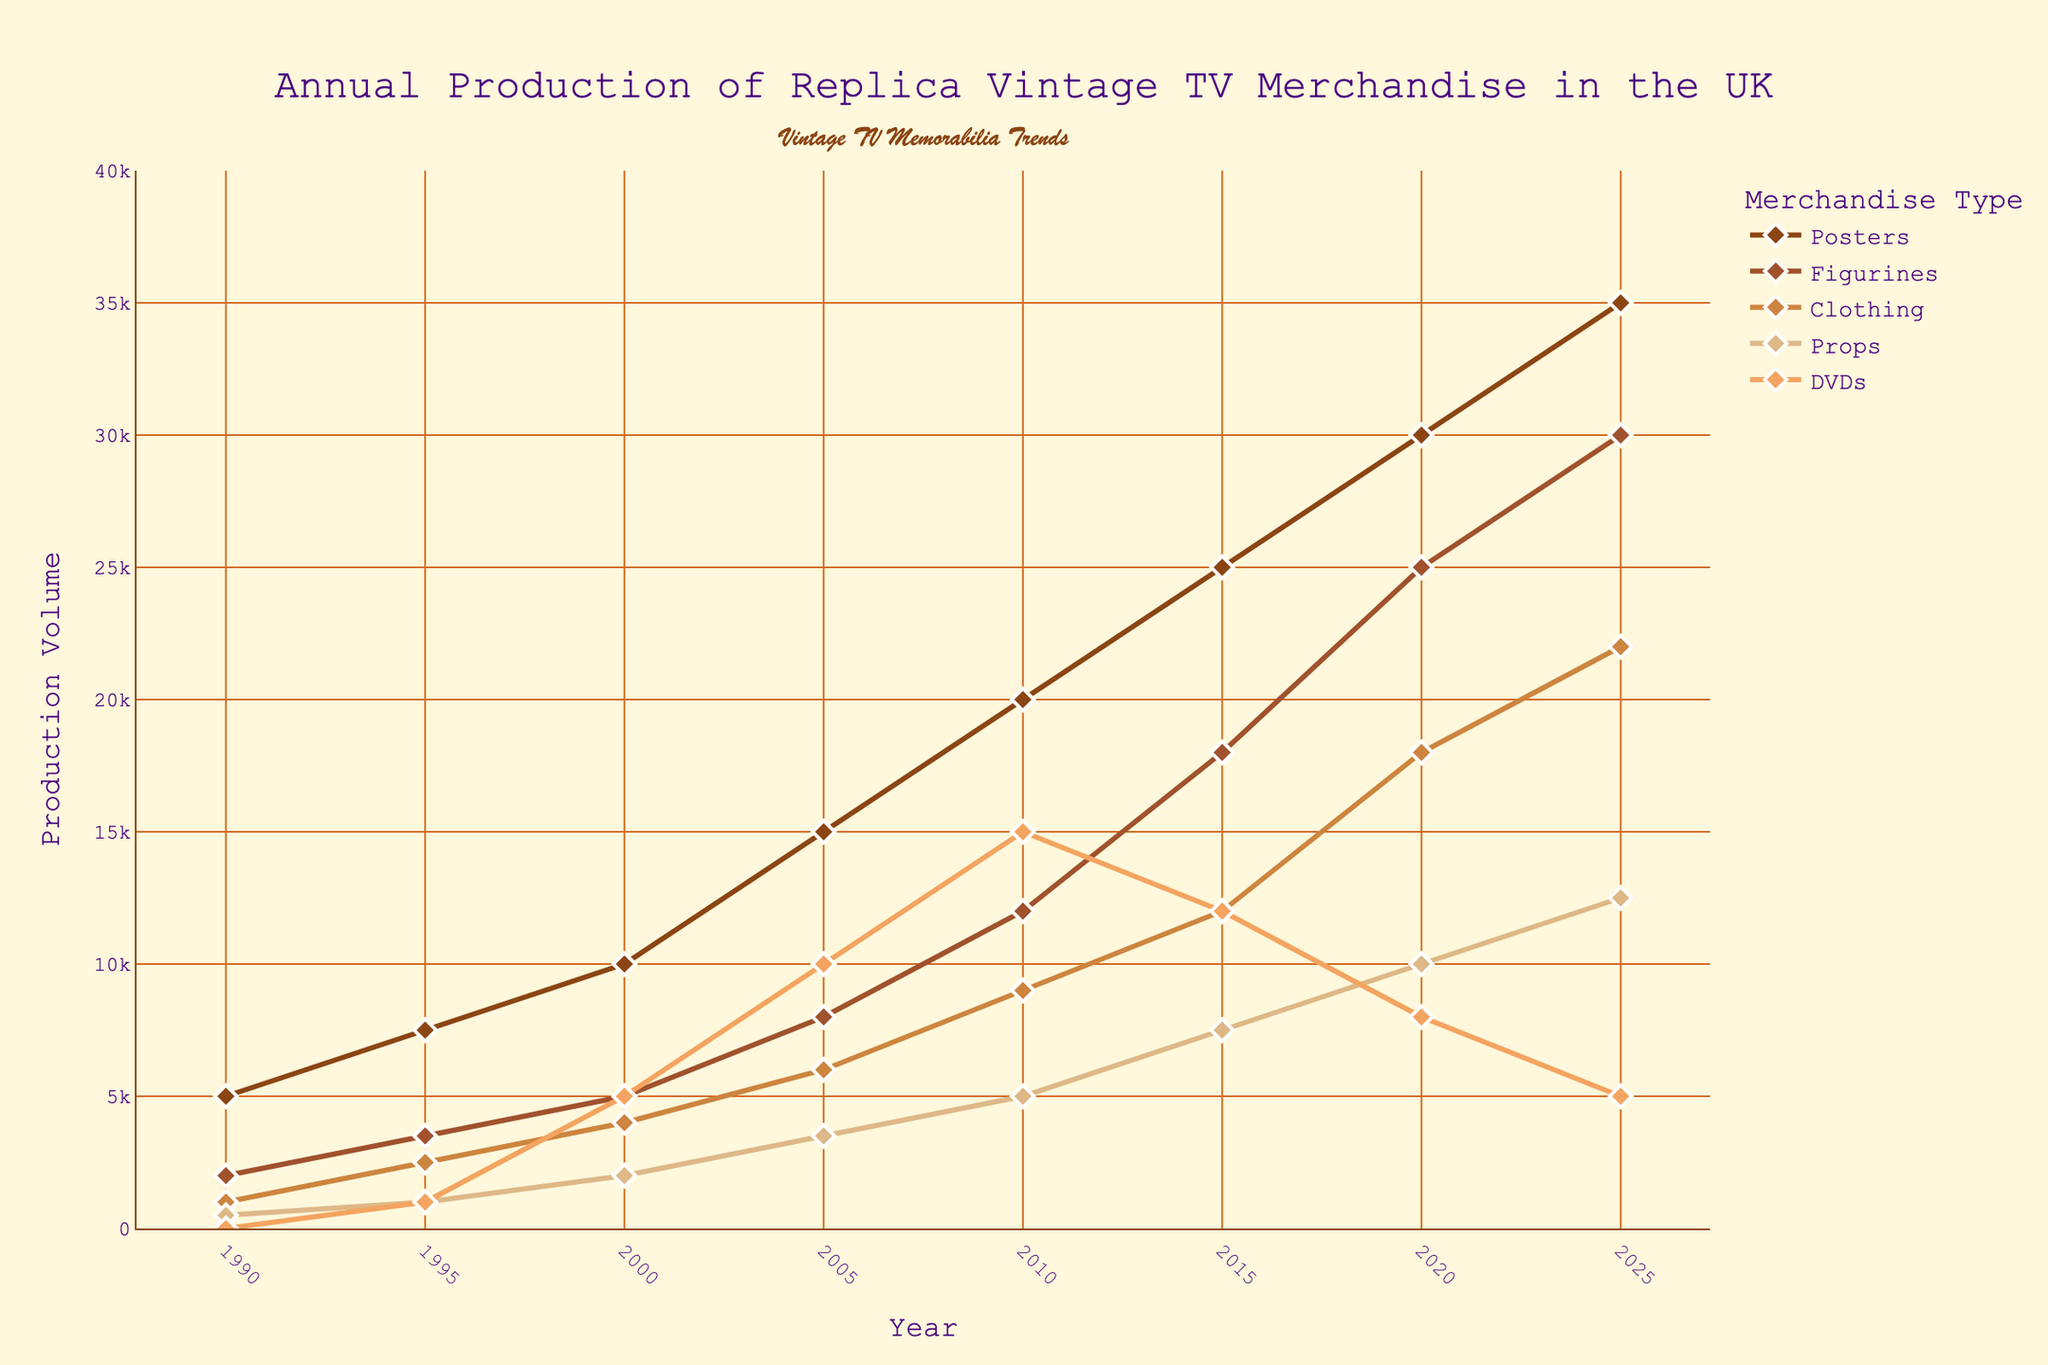What is the difference in the production volume of Posters between the years 1990 and 2025? To find the difference, locate the production volume of Posters for the years 1990 and 2025 on the y-axis. In 1990, Posters' production volume is 5000 units, and in 2025, it is 35000 units. Subtract the 1990 value from the 2025 value: 35000 - 5000 = 30000.
Answer: 30000 Which merchandise type had the highest production volume in 2010? Observe the distribution of data markers for the year 2010 across all merchandise types. The highest y-axis value is for DVDs, which stands at 15000 units.
Answer: DVDs In which year did Clothing production reach 12000 units? Trace the line corresponding to Clothing across the x-axis until the marker reaches the 12000 unit level on the y-axis. The year where this occurs is 2015.
Answer: 2015 How does the production volume of DVDs in 2005 compare to 2025? Identify the data points for DVDs in the years 2005 and 2025. In 2005, the volume is 10000 units, while in 2025 it reduces to 5000 units. Comparing these values, the production volume of DVDs in 2025 is half of what it was in 2005.
Answer: Decreased by half What is the average production volume of Props over the period from 1990 to 2025? Sum the production volumes of Props for the years 1990 (500), 1995 (1000), 2000 (2000), 2005 (3500), 2010 (5000), 2015 (7500), 2020 (10000), and 2025 (12500). The total is 41500. The average is calculated by dividing the total by the number of years (8): 41500 / 8 = 5187.5.
Answer: 5187.5 Which year saw the most significant increase in Figurines production from the previous year? Examine the intervals between each year for the Figurines line to find the largest vertical difference. The most significant increase occurs between the years 2015 (18000) and 2020 (25000). The increase is 25000 - 18000 = 7000.
Answer: Between 2015 and 2020 What color is used to represent the Clothing merchandise type? Observe the legend and the lines in the plot to identify the color associated with each type. Clothing is represented by the third line/marker, which is colored tan.
Answer: Tan How many years show a production volume of Props exceeding 10000 units? Examine the Prop line and identify the years when its value exceeds 10000 units on the y-axis. The years that meet this criterion are 2020 and 2025, totaling 2 years.
Answer: 2 What is the combined production volume of Posters and Figurines in the year 2000? Locate the production volumes of Posters and Figurines for the year 2000. Posters have a volume of 10000 units and Figurines have 5000 units. The combined volume is 10000 + 5000 = 15000.
Answer: 15000 Which merchandise type was produced the least in 1995? Check the legend and lines to find the production volume of each merchandise type in 1995. The least production was for Props with a volume of 1000 units.
Answer: Props 